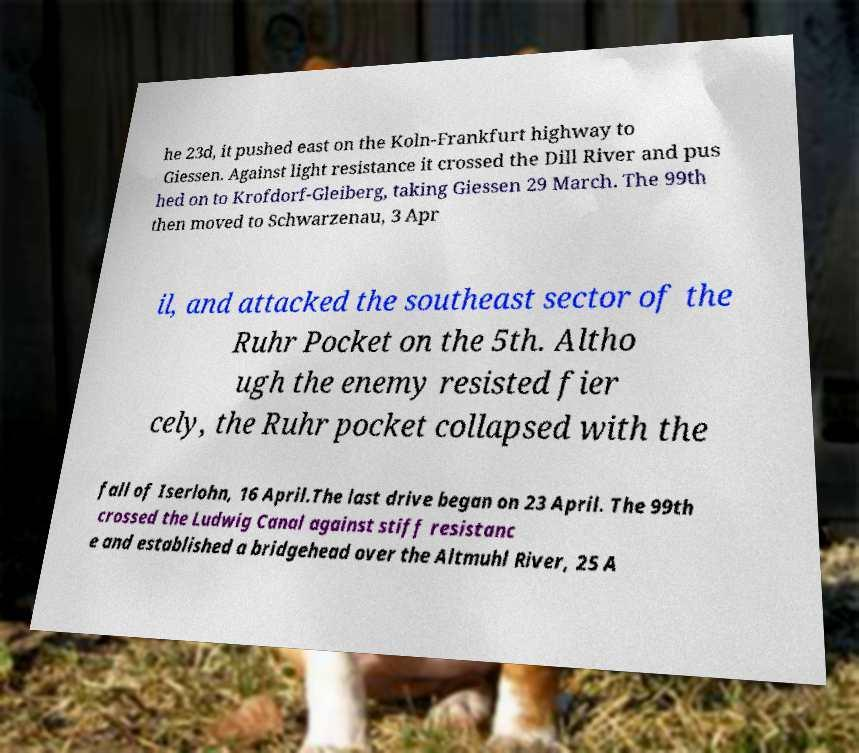What messages or text are displayed in this image? I need them in a readable, typed format. he 23d, it pushed east on the Koln-Frankfurt highway to Giessen. Against light resistance it crossed the Dill River and pus hed on to Krofdorf-Gleiberg, taking Giessen 29 March. The 99th then moved to Schwarzenau, 3 Apr il, and attacked the southeast sector of the Ruhr Pocket on the 5th. Altho ugh the enemy resisted fier cely, the Ruhr pocket collapsed with the fall of Iserlohn, 16 April.The last drive began on 23 April. The 99th crossed the Ludwig Canal against stiff resistanc e and established a bridgehead over the Altmuhl River, 25 A 